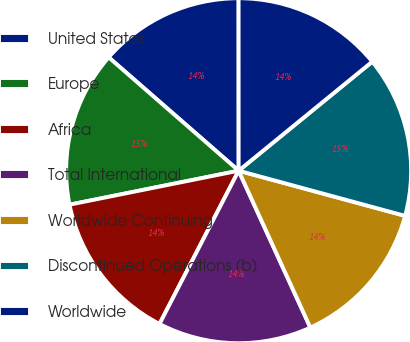Convert chart. <chart><loc_0><loc_0><loc_500><loc_500><pie_chart><fcel>United States<fcel>Europe<fcel>Africa<fcel>Total International<fcel>Worldwide Continuing<fcel>Discontinued Operations (b)<fcel>Worldwide<nl><fcel>13.58%<fcel>14.57%<fcel>14.26%<fcel>14.41%<fcel>13.96%<fcel>15.11%<fcel>14.11%<nl></chart> 